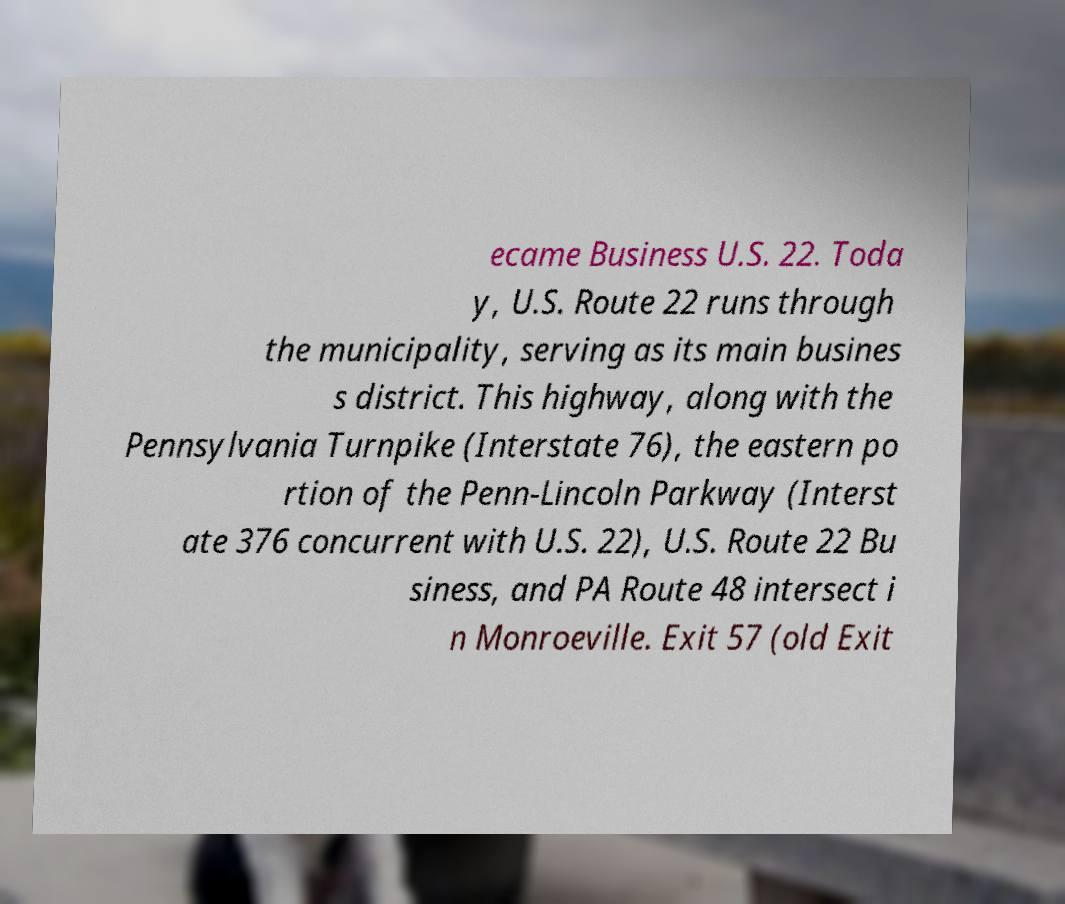Could you assist in decoding the text presented in this image and type it out clearly? ecame Business U.S. 22. Toda y, U.S. Route 22 runs through the municipality, serving as its main busines s district. This highway, along with the Pennsylvania Turnpike (Interstate 76), the eastern po rtion of the Penn-Lincoln Parkway (Interst ate 376 concurrent with U.S. 22), U.S. Route 22 Bu siness, and PA Route 48 intersect i n Monroeville. Exit 57 (old Exit 